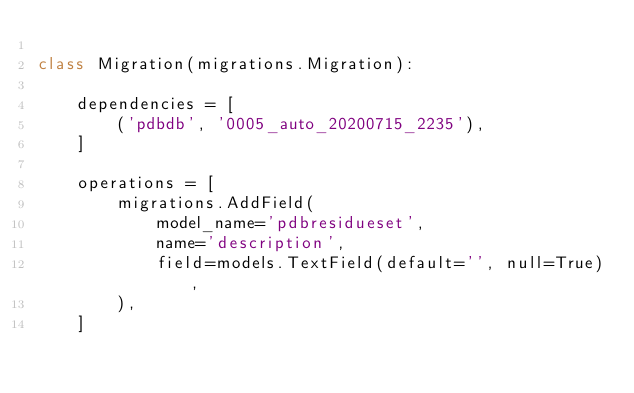<code> <loc_0><loc_0><loc_500><loc_500><_Python_>
class Migration(migrations.Migration):

    dependencies = [
        ('pdbdb', '0005_auto_20200715_2235'),
    ]

    operations = [
        migrations.AddField(
            model_name='pdbresidueset',
            name='description',
            field=models.TextField(default='', null=True),
        ),
    ]
</code> 